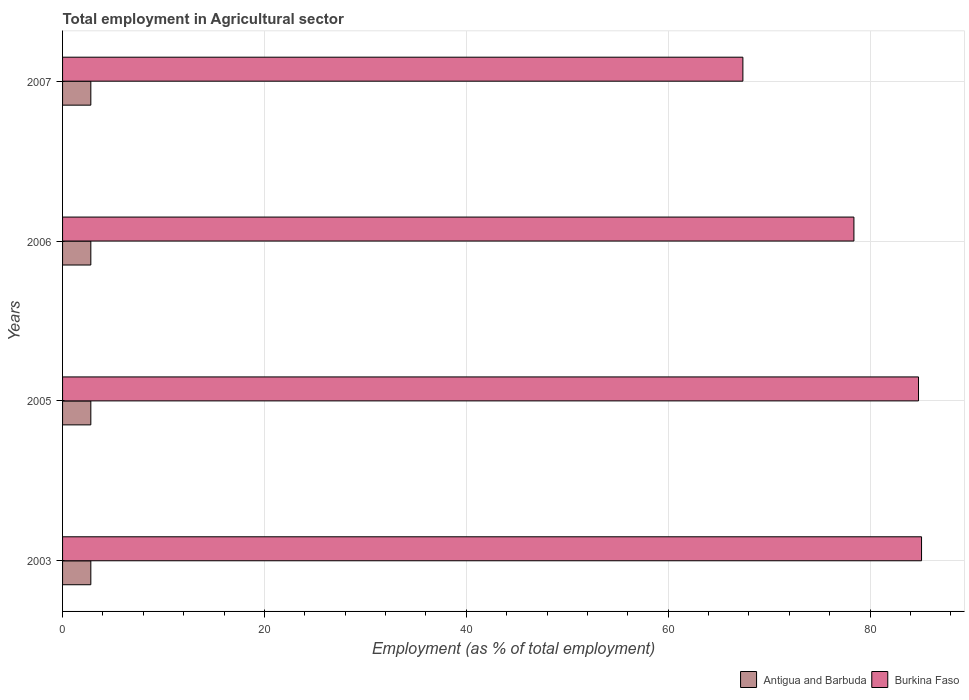How many different coloured bars are there?
Your answer should be compact. 2. Are the number of bars on each tick of the Y-axis equal?
Your answer should be compact. Yes. How many bars are there on the 3rd tick from the top?
Give a very brief answer. 2. How many bars are there on the 2nd tick from the bottom?
Make the answer very short. 2. In how many cases, is the number of bars for a given year not equal to the number of legend labels?
Keep it short and to the point. 0. What is the employment in agricultural sector in Antigua and Barbuda in 2006?
Keep it short and to the point. 2.8. Across all years, what is the maximum employment in agricultural sector in Burkina Faso?
Keep it short and to the point. 85.1. Across all years, what is the minimum employment in agricultural sector in Antigua and Barbuda?
Your response must be concise. 2.8. What is the total employment in agricultural sector in Antigua and Barbuda in the graph?
Your response must be concise. 11.2. What is the difference between the employment in agricultural sector in Burkina Faso in 2003 and that in 2007?
Offer a terse response. 17.7. What is the difference between the employment in agricultural sector in Burkina Faso in 2005 and the employment in agricultural sector in Antigua and Barbuda in 2007?
Provide a short and direct response. 82. What is the average employment in agricultural sector in Antigua and Barbuda per year?
Keep it short and to the point. 2.8. In the year 2007, what is the difference between the employment in agricultural sector in Antigua and Barbuda and employment in agricultural sector in Burkina Faso?
Keep it short and to the point. -64.6. In how many years, is the employment in agricultural sector in Burkina Faso greater than 72 %?
Offer a terse response. 3. What is the ratio of the employment in agricultural sector in Burkina Faso in 2003 to that in 2006?
Make the answer very short. 1.09. Is the employment in agricultural sector in Burkina Faso in 2005 less than that in 2007?
Your answer should be compact. No. Is the difference between the employment in agricultural sector in Antigua and Barbuda in 2003 and 2006 greater than the difference between the employment in agricultural sector in Burkina Faso in 2003 and 2006?
Provide a short and direct response. No. What is the difference between the highest and the second highest employment in agricultural sector in Burkina Faso?
Offer a terse response. 0.3. In how many years, is the employment in agricultural sector in Antigua and Barbuda greater than the average employment in agricultural sector in Antigua and Barbuda taken over all years?
Keep it short and to the point. 0. What does the 2nd bar from the top in 2005 represents?
Ensure brevity in your answer.  Antigua and Barbuda. What does the 2nd bar from the bottom in 2006 represents?
Your answer should be compact. Burkina Faso. What is the difference between two consecutive major ticks on the X-axis?
Give a very brief answer. 20. Does the graph contain any zero values?
Ensure brevity in your answer.  No. Does the graph contain grids?
Keep it short and to the point. Yes. Where does the legend appear in the graph?
Your answer should be very brief. Bottom right. How many legend labels are there?
Make the answer very short. 2. How are the legend labels stacked?
Make the answer very short. Horizontal. What is the title of the graph?
Your answer should be compact. Total employment in Agricultural sector. What is the label or title of the X-axis?
Ensure brevity in your answer.  Employment (as % of total employment). What is the label or title of the Y-axis?
Provide a succinct answer. Years. What is the Employment (as % of total employment) in Antigua and Barbuda in 2003?
Keep it short and to the point. 2.8. What is the Employment (as % of total employment) of Burkina Faso in 2003?
Provide a short and direct response. 85.1. What is the Employment (as % of total employment) of Antigua and Barbuda in 2005?
Provide a short and direct response. 2.8. What is the Employment (as % of total employment) of Burkina Faso in 2005?
Offer a very short reply. 84.8. What is the Employment (as % of total employment) of Antigua and Barbuda in 2006?
Provide a short and direct response. 2.8. What is the Employment (as % of total employment) in Burkina Faso in 2006?
Offer a terse response. 78.4. What is the Employment (as % of total employment) in Antigua and Barbuda in 2007?
Ensure brevity in your answer.  2.8. What is the Employment (as % of total employment) in Burkina Faso in 2007?
Your response must be concise. 67.4. Across all years, what is the maximum Employment (as % of total employment) in Antigua and Barbuda?
Offer a terse response. 2.8. Across all years, what is the maximum Employment (as % of total employment) of Burkina Faso?
Provide a succinct answer. 85.1. Across all years, what is the minimum Employment (as % of total employment) in Antigua and Barbuda?
Provide a short and direct response. 2.8. Across all years, what is the minimum Employment (as % of total employment) in Burkina Faso?
Ensure brevity in your answer.  67.4. What is the total Employment (as % of total employment) of Antigua and Barbuda in the graph?
Your answer should be compact. 11.2. What is the total Employment (as % of total employment) of Burkina Faso in the graph?
Provide a succinct answer. 315.7. What is the difference between the Employment (as % of total employment) in Antigua and Barbuda in 2003 and that in 2005?
Give a very brief answer. 0. What is the difference between the Employment (as % of total employment) in Antigua and Barbuda in 2003 and that in 2006?
Make the answer very short. 0. What is the difference between the Employment (as % of total employment) of Antigua and Barbuda in 2005 and that in 2007?
Keep it short and to the point. 0. What is the difference between the Employment (as % of total employment) of Antigua and Barbuda in 2003 and the Employment (as % of total employment) of Burkina Faso in 2005?
Your response must be concise. -82. What is the difference between the Employment (as % of total employment) of Antigua and Barbuda in 2003 and the Employment (as % of total employment) of Burkina Faso in 2006?
Your answer should be compact. -75.6. What is the difference between the Employment (as % of total employment) in Antigua and Barbuda in 2003 and the Employment (as % of total employment) in Burkina Faso in 2007?
Offer a very short reply. -64.6. What is the difference between the Employment (as % of total employment) in Antigua and Barbuda in 2005 and the Employment (as % of total employment) in Burkina Faso in 2006?
Make the answer very short. -75.6. What is the difference between the Employment (as % of total employment) in Antigua and Barbuda in 2005 and the Employment (as % of total employment) in Burkina Faso in 2007?
Provide a short and direct response. -64.6. What is the difference between the Employment (as % of total employment) of Antigua and Barbuda in 2006 and the Employment (as % of total employment) of Burkina Faso in 2007?
Your answer should be very brief. -64.6. What is the average Employment (as % of total employment) of Antigua and Barbuda per year?
Offer a very short reply. 2.8. What is the average Employment (as % of total employment) in Burkina Faso per year?
Provide a short and direct response. 78.92. In the year 2003, what is the difference between the Employment (as % of total employment) in Antigua and Barbuda and Employment (as % of total employment) in Burkina Faso?
Provide a succinct answer. -82.3. In the year 2005, what is the difference between the Employment (as % of total employment) in Antigua and Barbuda and Employment (as % of total employment) in Burkina Faso?
Your answer should be compact. -82. In the year 2006, what is the difference between the Employment (as % of total employment) in Antigua and Barbuda and Employment (as % of total employment) in Burkina Faso?
Ensure brevity in your answer.  -75.6. In the year 2007, what is the difference between the Employment (as % of total employment) in Antigua and Barbuda and Employment (as % of total employment) in Burkina Faso?
Give a very brief answer. -64.6. What is the ratio of the Employment (as % of total employment) of Antigua and Barbuda in 2003 to that in 2005?
Provide a succinct answer. 1. What is the ratio of the Employment (as % of total employment) of Antigua and Barbuda in 2003 to that in 2006?
Your response must be concise. 1. What is the ratio of the Employment (as % of total employment) in Burkina Faso in 2003 to that in 2006?
Give a very brief answer. 1.09. What is the ratio of the Employment (as % of total employment) in Antigua and Barbuda in 2003 to that in 2007?
Keep it short and to the point. 1. What is the ratio of the Employment (as % of total employment) in Burkina Faso in 2003 to that in 2007?
Your answer should be very brief. 1.26. What is the ratio of the Employment (as % of total employment) of Burkina Faso in 2005 to that in 2006?
Your answer should be very brief. 1.08. What is the ratio of the Employment (as % of total employment) of Antigua and Barbuda in 2005 to that in 2007?
Provide a succinct answer. 1. What is the ratio of the Employment (as % of total employment) in Burkina Faso in 2005 to that in 2007?
Provide a short and direct response. 1.26. What is the ratio of the Employment (as % of total employment) of Antigua and Barbuda in 2006 to that in 2007?
Provide a succinct answer. 1. What is the ratio of the Employment (as % of total employment) in Burkina Faso in 2006 to that in 2007?
Your response must be concise. 1.16. What is the difference between the highest and the second highest Employment (as % of total employment) of Antigua and Barbuda?
Offer a terse response. 0. What is the difference between the highest and the second highest Employment (as % of total employment) of Burkina Faso?
Offer a terse response. 0.3. What is the difference between the highest and the lowest Employment (as % of total employment) of Burkina Faso?
Your answer should be very brief. 17.7. 